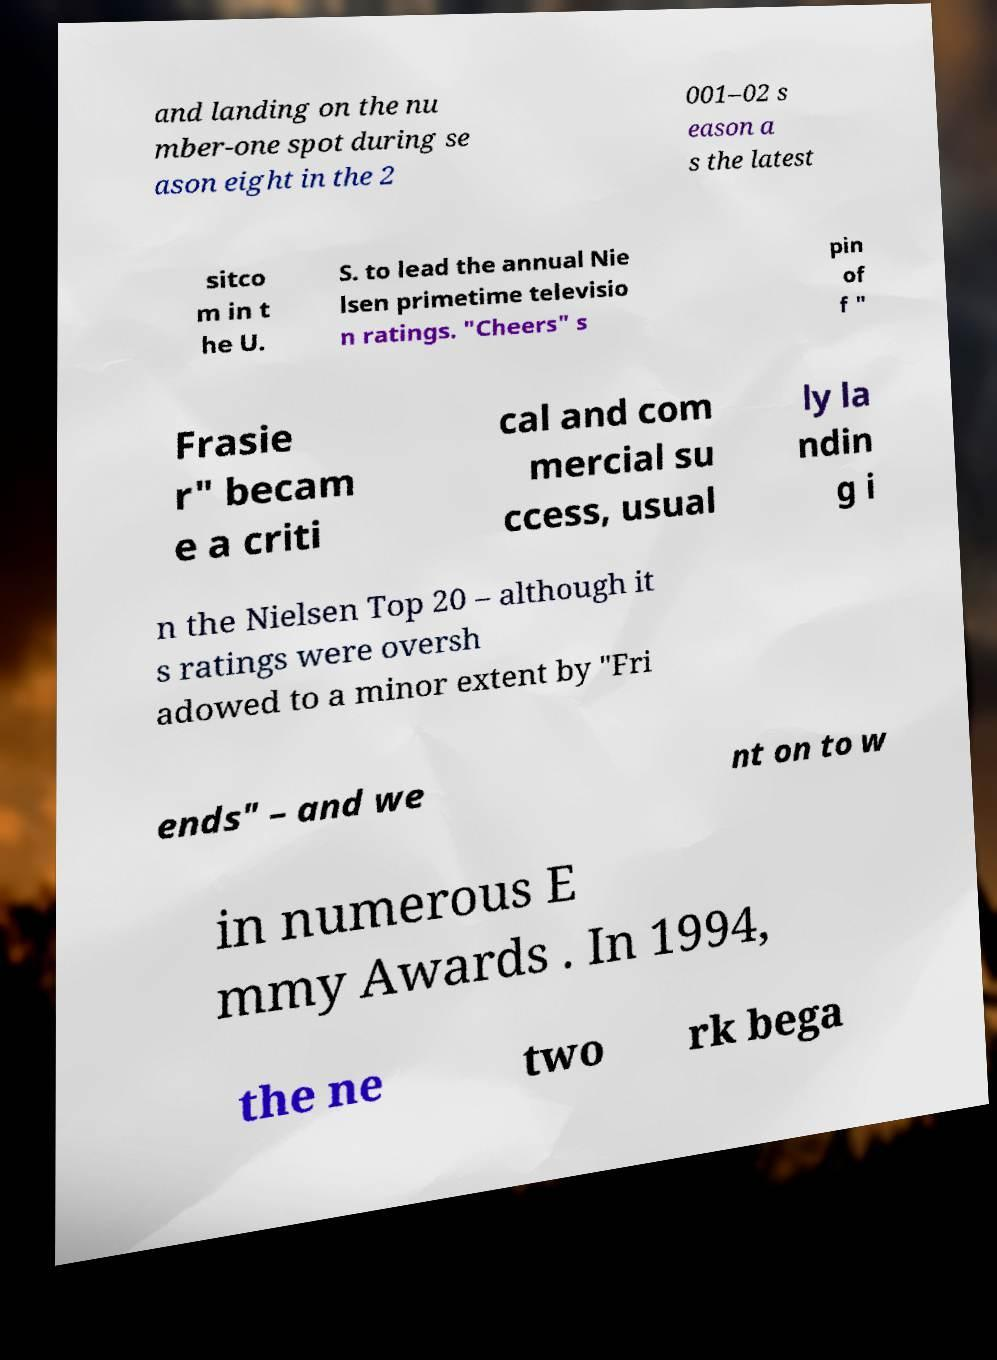Could you assist in decoding the text presented in this image and type it out clearly? and landing on the nu mber-one spot during se ason eight in the 2 001–02 s eason a s the latest sitco m in t he U. S. to lead the annual Nie lsen primetime televisio n ratings. "Cheers" s pin of f " Frasie r" becam e a criti cal and com mercial su ccess, usual ly la ndin g i n the Nielsen Top 20 – although it s ratings were oversh adowed to a minor extent by "Fri ends" – and we nt on to w in numerous E mmy Awards . In 1994, the ne two rk bega 